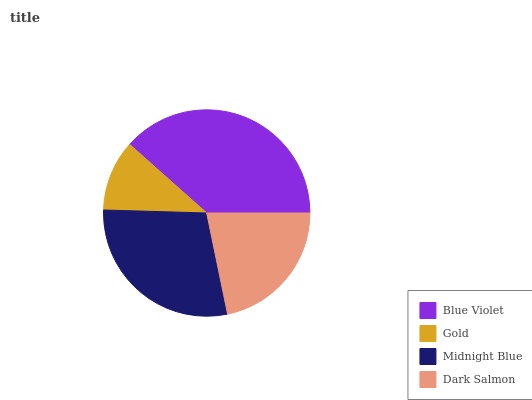Is Gold the minimum?
Answer yes or no. Yes. Is Blue Violet the maximum?
Answer yes or no. Yes. Is Midnight Blue the minimum?
Answer yes or no. No. Is Midnight Blue the maximum?
Answer yes or no. No. Is Midnight Blue greater than Gold?
Answer yes or no. Yes. Is Gold less than Midnight Blue?
Answer yes or no. Yes. Is Gold greater than Midnight Blue?
Answer yes or no. No. Is Midnight Blue less than Gold?
Answer yes or no. No. Is Midnight Blue the high median?
Answer yes or no. Yes. Is Dark Salmon the low median?
Answer yes or no. Yes. Is Blue Violet the high median?
Answer yes or no. No. Is Midnight Blue the low median?
Answer yes or no. No. 